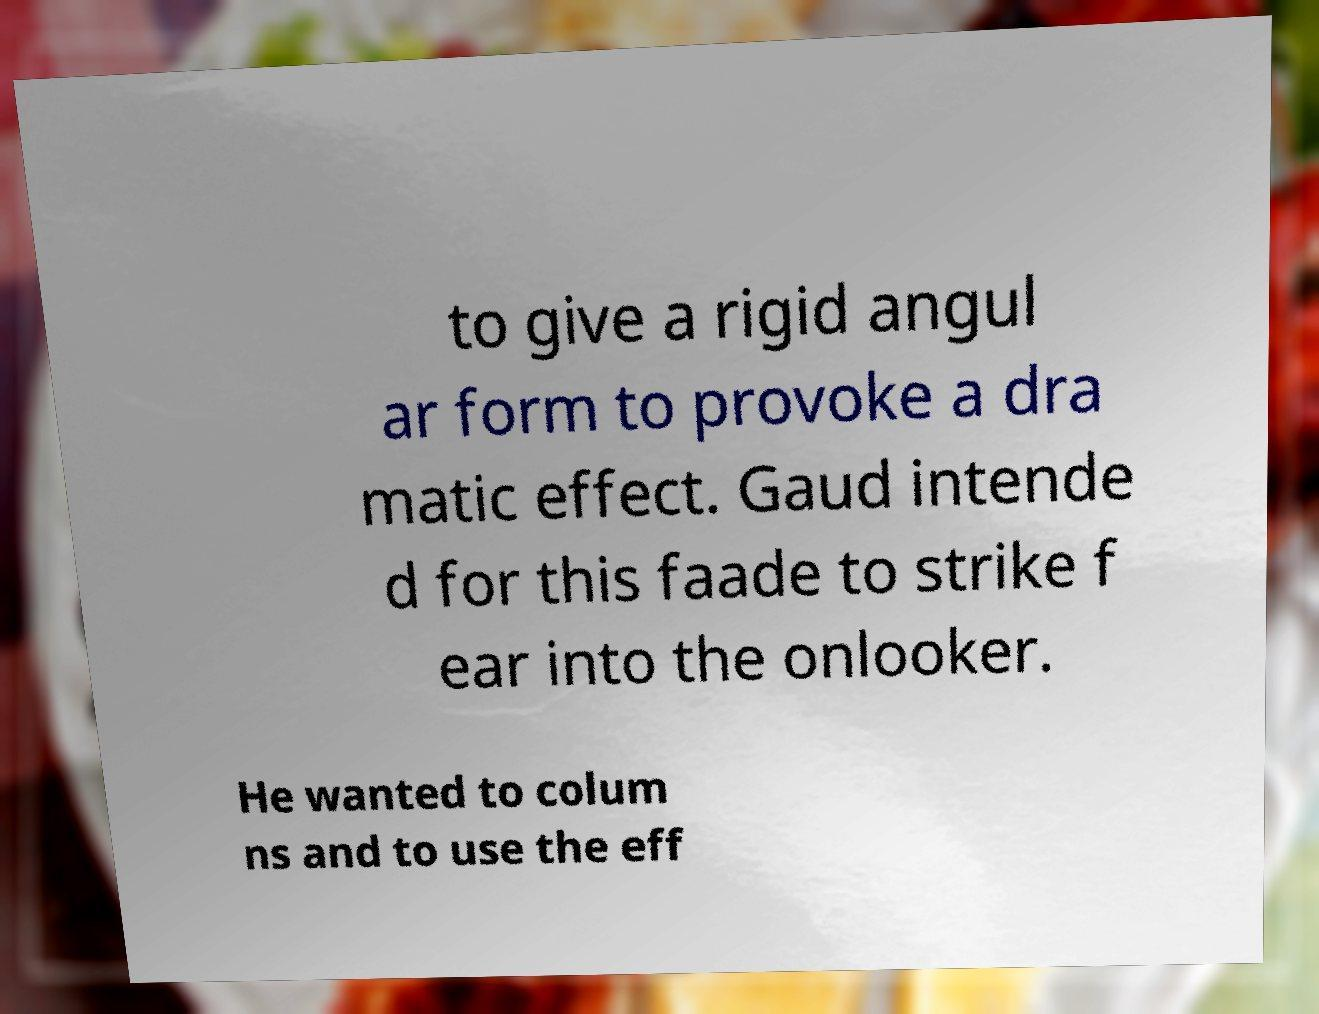Please read and relay the text visible in this image. What does it say? to give a rigid angul ar form to provoke a dra matic effect. Gaud intende d for this faade to strike f ear into the onlooker. He wanted to colum ns and to use the eff 